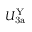<formula> <loc_0><loc_0><loc_500><loc_500>U _ { 3 a } ^ { Y }</formula> 